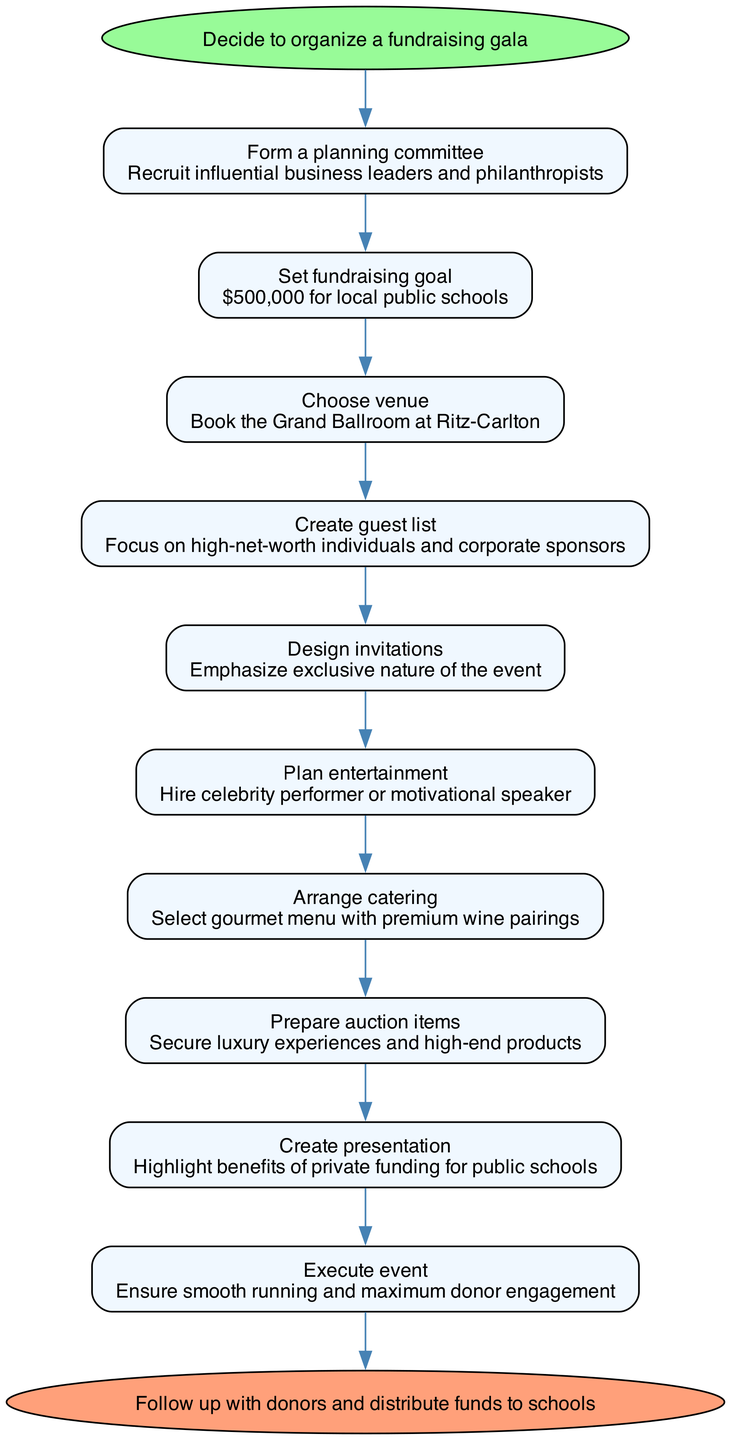What is the first step in organizing the fundraising gala? The first step mentioned in the diagram is "Decide to organize a fundraising gala." This is clearly indicated as the starting point of the flow chart.
Answer: Decide to organize a fundraising gala How much is the fundraising goal? The fundraising goal is specified as "$500,000 for local public schools." This information is directly listed under the corresponding step.
Answer: $500,000 for local public schools What is the venue chosen for the event? The chosen venue is specified as "Grand Ballroom at Ritz-Carlton." This detail is presented in the step regarding venue selection.
Answer: Grand Ballroom at Ritz-Carlton How many steps are involved in organizing the gala? By counting the steps provided in the diagram, there are a total of ten steps, from forming the planning committee to following up with donors.
Answer: 10 Which step focuses on luxury items for the auction? The step "Prepare auction items" emphasizes securing luxury experiences and high-end products. This is directly represented as part of the fundraising process.
Answer: Prepare auction items What is emphasized in the invitation design step? The design of the invitations emphasizes the "exclusive nature of the event." This focus is explicitly stated in the corresponding step of the diagram.
Answer: Exclusive nature of the event Which step involves the entertainment arrangements? The step titled "Plan entertainment" indicates that arrangements will include hiring a celebrity performer or motivational speaker. This is the main focus of that step.
Answer: Hire celebrity performer or motivational speaker What follows the execution of the event? Following the execution of the event, the next action is "Follow up with donors and distribute funds to schools." This represents the final step in the process.
Answer: Follow up with donors and distribute funds to schools What type of individuals should be included in the guest list? The guest list should focus on "high-net-worth individuals and corporate sponsors," as stated in the corresponding step. This is an essential part of attracting donations.
Answer: High-net-worth individuals and corporate sponsors Why is the presentation created? The presentation is created to "highlight benefits of private funding for public schools." This indicates the purpose of the presentation within the flow of the gala organization.
Answer: Highlight benefits of private funding for public schools 